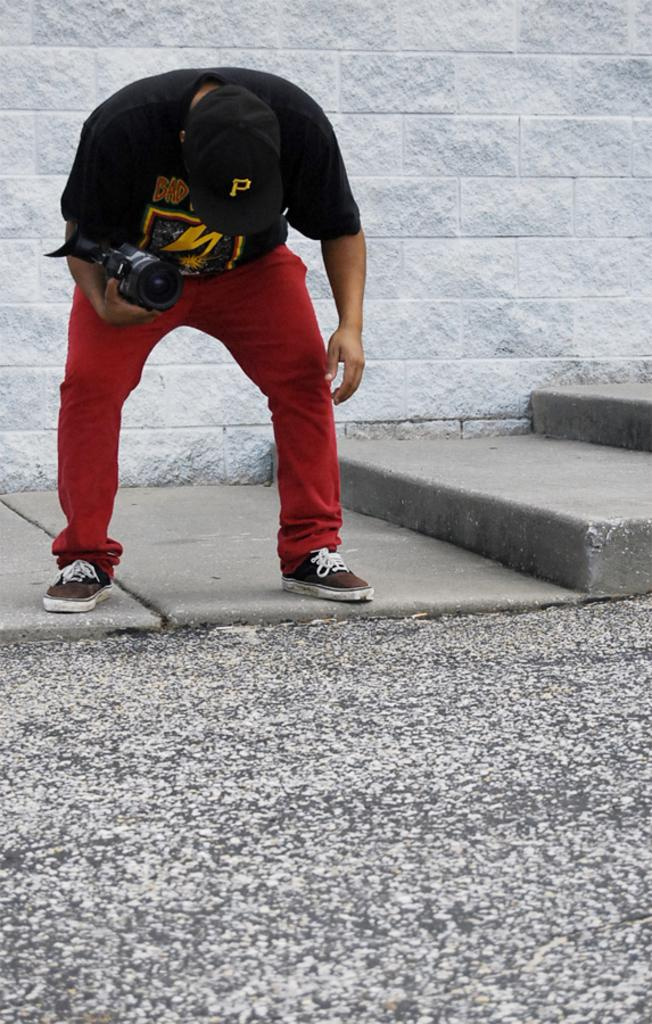Who is in the image? There is a man in the image. What is the man doing in the image? The man is standing in the image. What is the man holding in his hand? The man is holding a camera in his hand. What is the man wearing on his head? The man is wearing a cap. What architectural feature can be seen in the image? There are steps present in the image. What type of rice is the man cooking in the image? There is no rice present in the image; the man is holding a camera and wearing a cap. What type of substance is the judge holding in the image? There is no judge present in the image, nor is there any substance being held. 